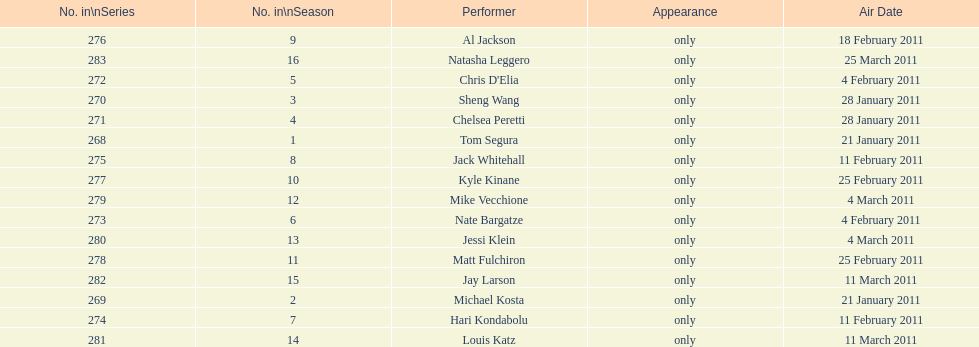What was hari's last name? Kondabolu. 